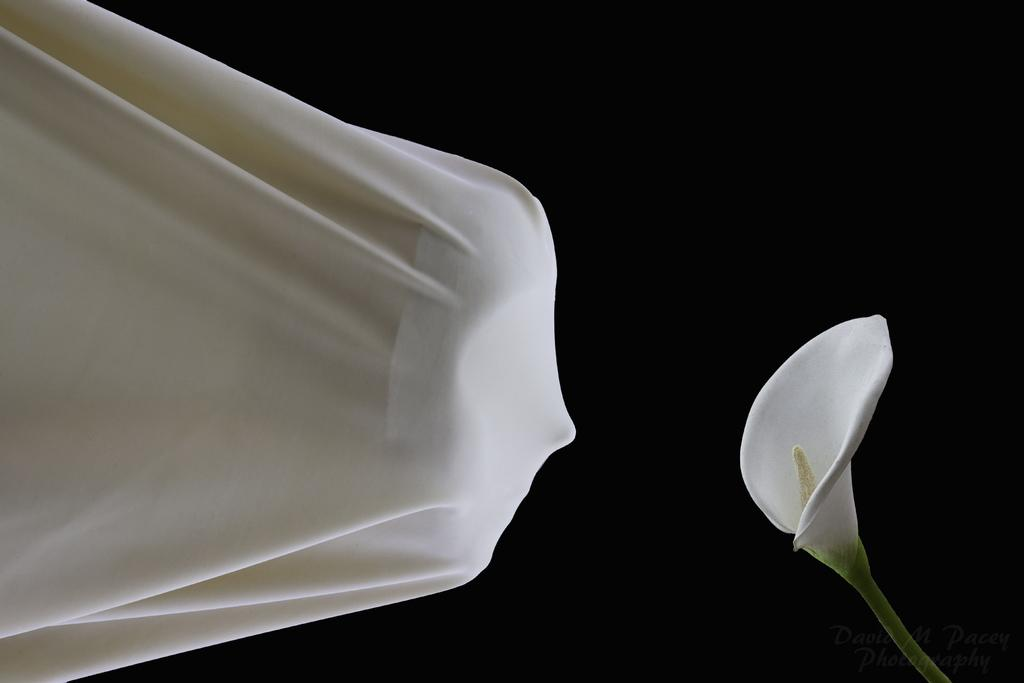What is the main object in the image? There is a cloth in the image. What is placed on the cloth? A mask is present on the cloth. What can be seen in front of the cloth? There is a flower in front of the cloth. What channel is the cloth tuned to in the image? The cloth is not a television or any device that can be tuned to a channel; it is a cloth with a mask on it and a flower in front of it. 